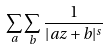Convert formula to latex. <formula><loc_0><loc_0><loc_500><loc_500>\sum _ { a } \sum _ { b } \frac { 1 } { | a z + b | ^ { s } }</formula> 